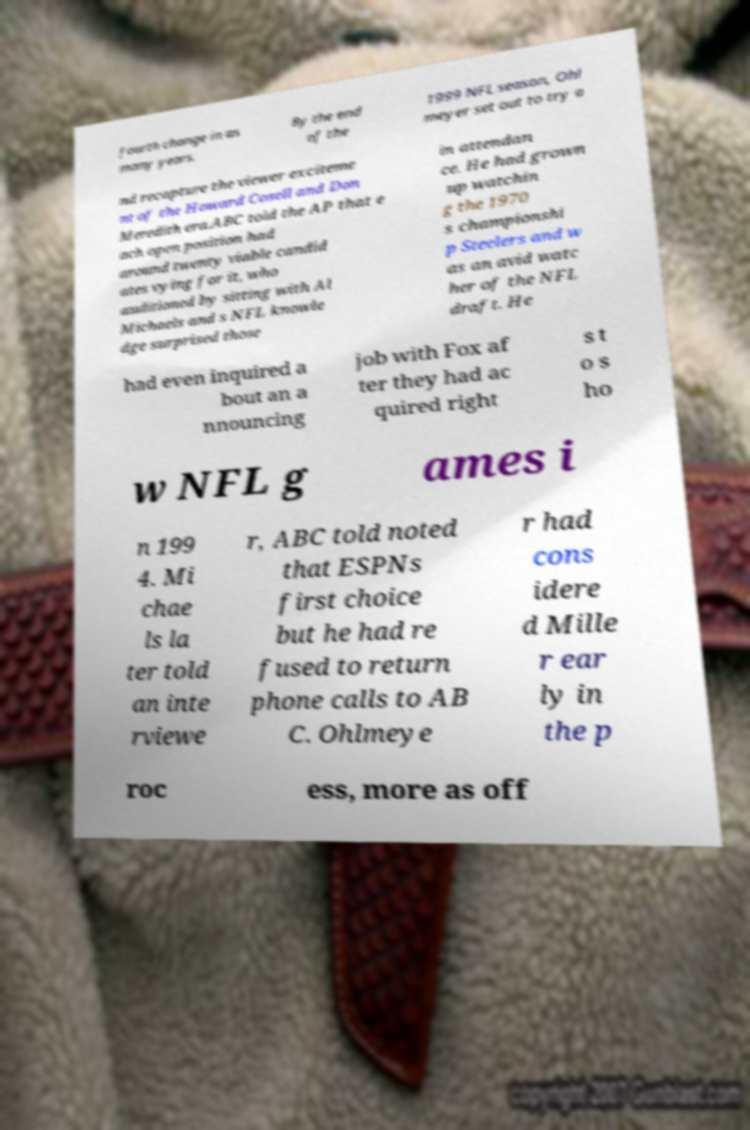Can you accurately transcribe the text from the provided image for me? fourth change in as many years. By the end of the 1999 NFL season, Ohl meyer set out to try a nd recapture the viewer exciteme nt of the Howard Cosell and Don Meredith era.ABC told the AP that e ach open position had around twenty viable candid ates vying for it, who auditioned by sitting with Al Michaels and s NFL knowle dge surprised those in attendan ce. He had grown up watchin g the 1970 s championshi p Steelers and w as an avid watc her of the NFL draft. He had even inquired a bout an a nnouncing job with Fox af ter they had ac quired right s t o s ho w NFL g ames i n 199 4. Mi chae ls la ter told an inte rviewe r, ABC told noted that ESPNs first choice but he had re fused to return phone calls to AB C. Ohlmeye r had cons idere d Mille r ear ly in the p roc ess, more as off 